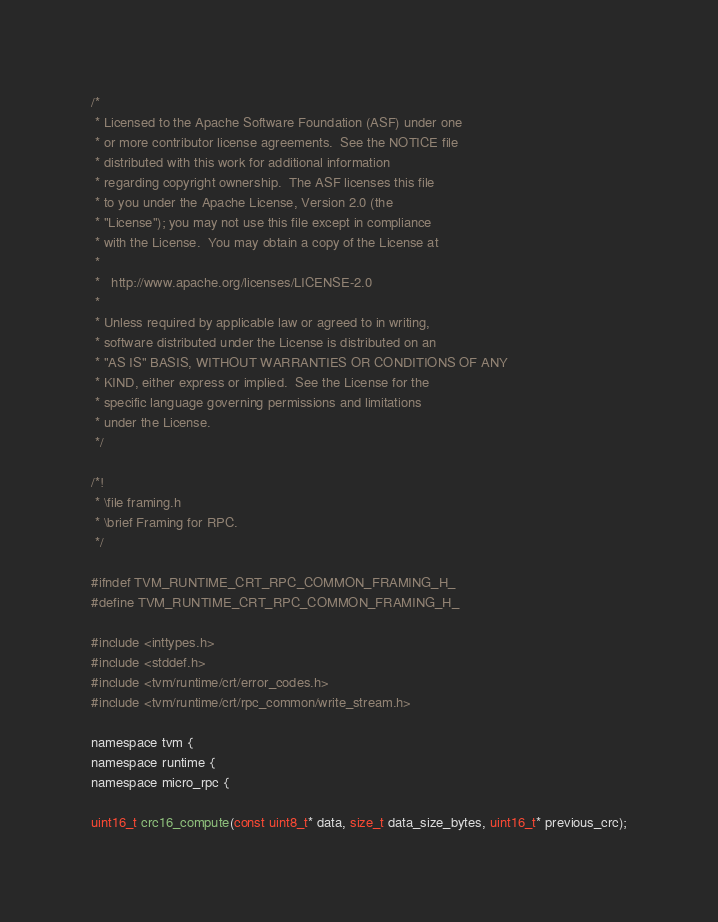<code> <loc_0><loc_0><loc_500><loc_500><_C_>/*
 * Licensed to the Apache Software Foundation (ASF) under one
 * or more contributor license agreements.  See the NOTICE file
 * distributed with this work for additional information
 * regarding copyright ownership.  The ASF licenses this file
 * to you under the Apache License, Version 2.0 (the
 * "License"); you may not use this file except in compliance
 * with the License.  You may obtain a copy of the License at
 *
 *   http://www.apache.org/licenses/LICENSE-2.0
 *
 * Unless required by applicable law or agreed to in writing,
 * software distributed under the License is distributed on an
 * "AS IS" BASIS, WITHOUT WARRANTIES OR CONDITIONS OF ANY
 * KIND, either express or implied.  See the License for the
 * specific language governing permissions and limitations
 * under the License.
 */

/*!
 * \file framing.h
 * \brief Framing for RPC.
 */

#ifndef TVM_RUNTIME_CRT_RPC_COMMON_FRAMING_H_
#define TVM_RUNTIME_CRT_RPC_COMMON_FRAMING_H_

#include <inttypes.h>
#include <stddef.h>
#include <tvm/runtime/crt/error_codes.h>
#include <tvm/runtime/crt/rpc_common/write_stream.h>

namespace tvm {
namespace runtime {
namespace micro_rpc {

uint16_t crc16_compute(const uint8_t* data, size_t data_size_bytes, uint16_t* previous_crc);
</code> 